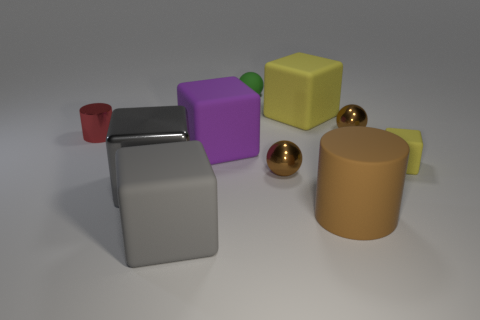How many spherical objects are there and what colors are they? There are two spherical objects in the image. One is a small, green sphere, and the other is a larger golden sphere. Each has a smooth, reflective surface, highlighting their distinct colors. Could you describe the position of the golden sphere in relation to the other objects? The golden sphere is positioned to the right of the image, resting near a cylindrical, beige object. It's in front of the two grey blocks and to the right of the yellow cube. 